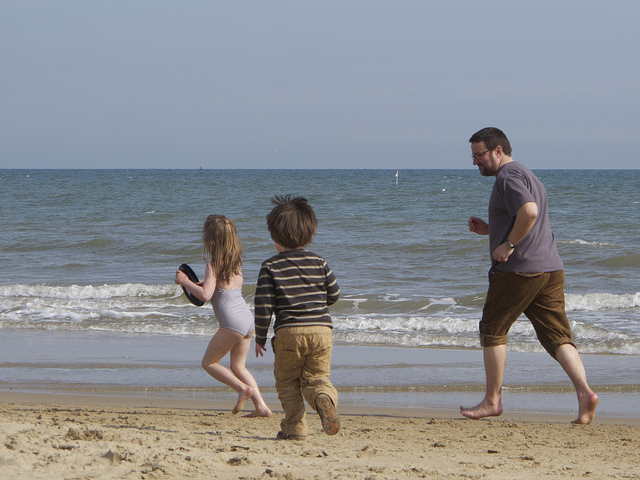<image>Which man is in blue? It is ambiguous which man is in blue without the image. Which man is in blue? I am not sure which man is in blue. It is unclear from the provided information. 